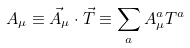<formula> <loc_0><loc_0><loc_500><loc_500>A _ { \mu } \equiv \vec { A } _ { \mu } \cdot \vec { T } \equiv \sum _ { a } A _ { \mu } ^ { a } T ^ { a }</formula> 